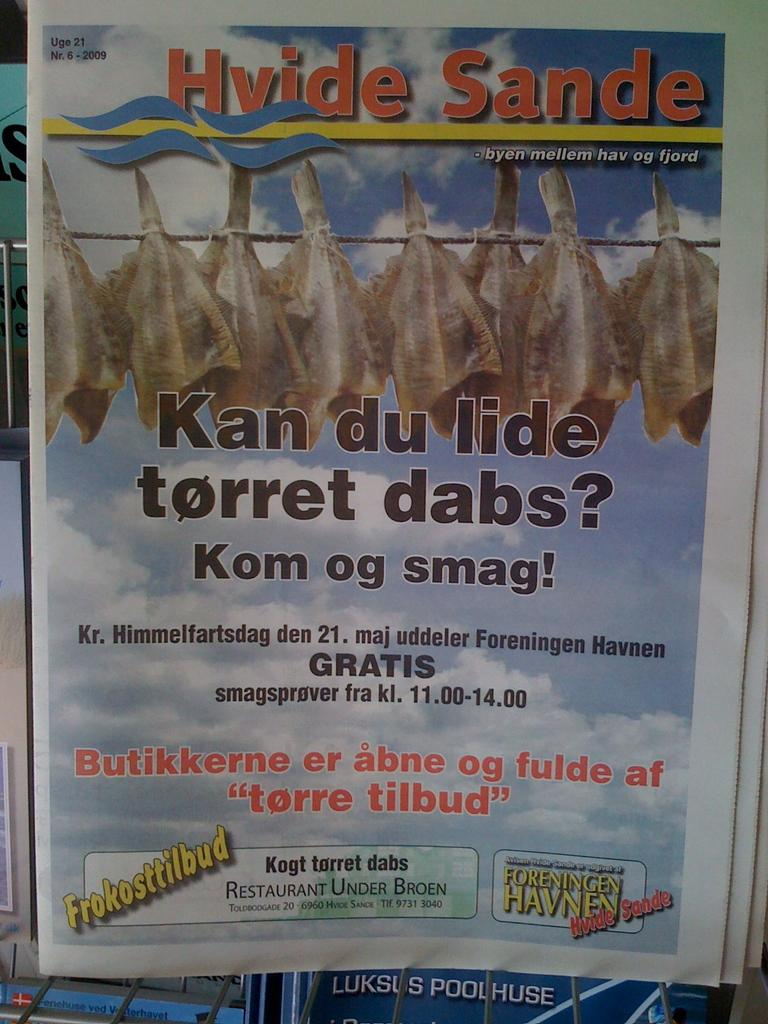What is the main object in the image? There is a paper in a metal stand in the image. What is attached to the paper? There are objects tied to ropes on the paper. What can be seen in the background of the image? The sky is visible in the image. Is there any text on the paper? Yes, there is writing on the paper. What type of trucks can be seen driving under the paper in the image? There are no trucks present in the image, and the paper is not suspended above any vehicles. 